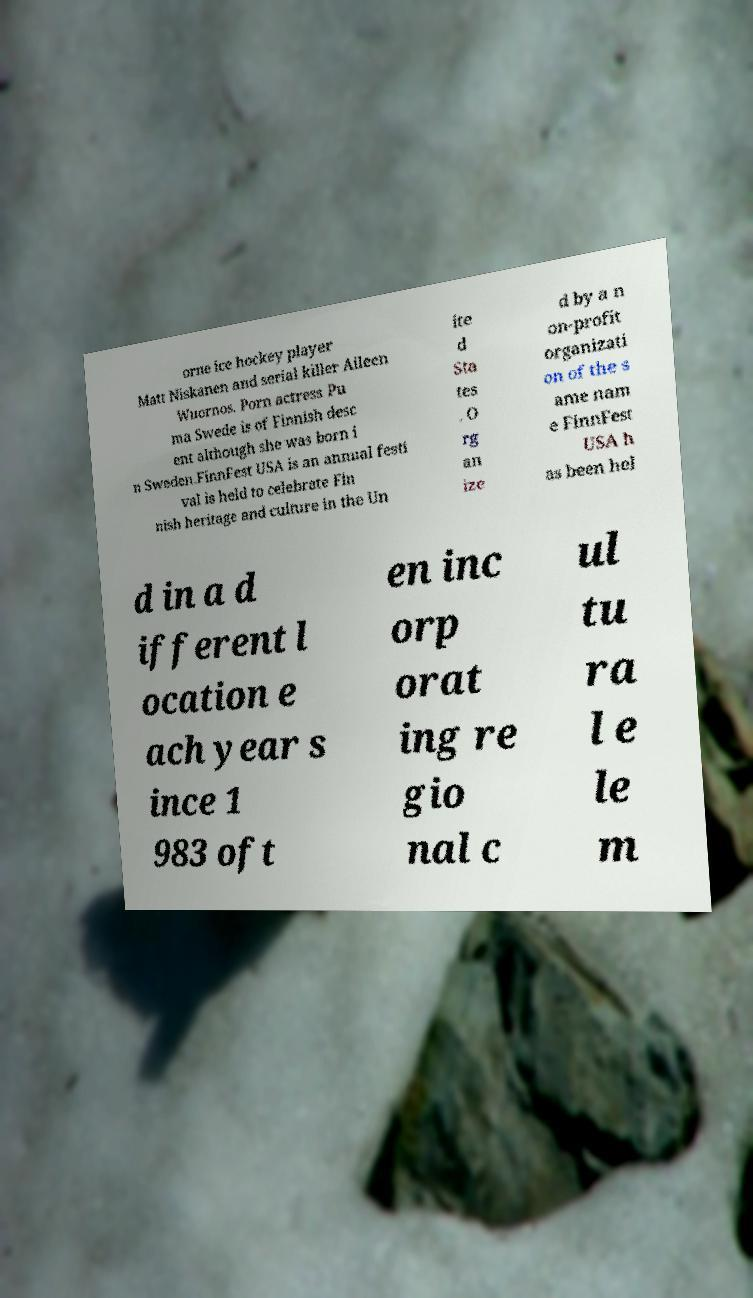Please identify and transcribe the text found in this image. orne ice hockey player Matt Niskanen and serial killer Aileen Wuornos. Porn actress Pu ma Swede is of Finnish desc ent although she was born i n Sweden.FinnFest USA is an annual festi val is held to celebrate Fin nish heritage and culture in the Un ite d Sta tes . O rg an ize d by a n on-profit organizati on of the s ame nam e FinnFest USA h as been hel d in a d ifferent l ocation e ach year s ince 1 983 oft en inc orp orat ing re gio nal c ul tu ra l e le m 